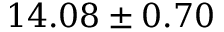<formula> <loc_0><loc_0><loc_500><loc_500>1 4 . 0 8 \pm 0 . 7 0</formula> 